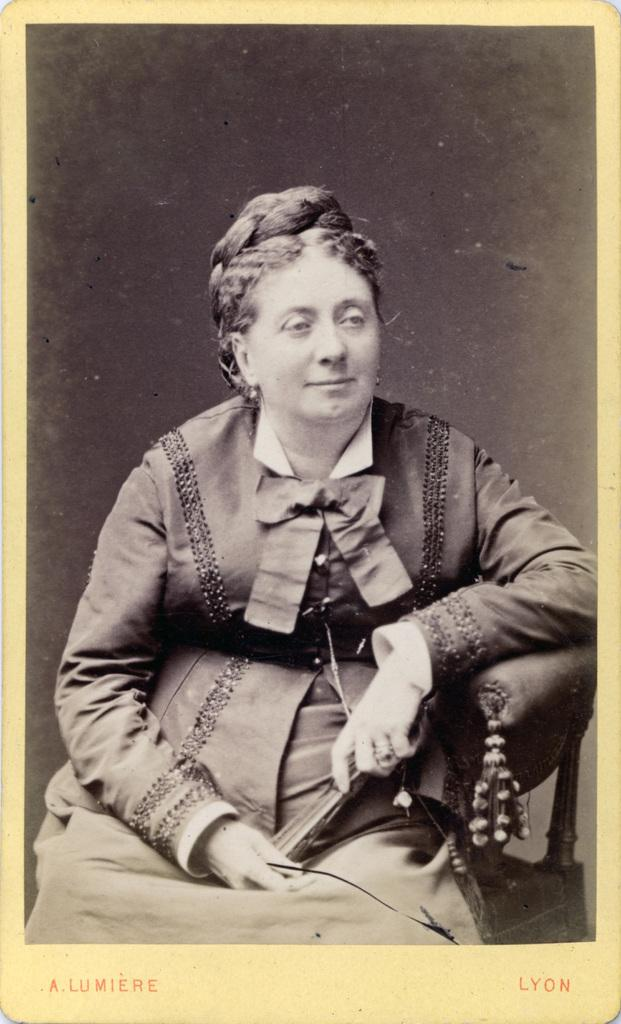Who is present in the image? There is a woman in the image. What is the woman doing in the image? The woman is sitting in a chair. What can be seen below the chair in the image? There is text or writing visible below the chair. What type of shop can be seen in the background of the image? There is no shop visible in the image; it only features a woman sitting in a chair with text or writing below the chair. 